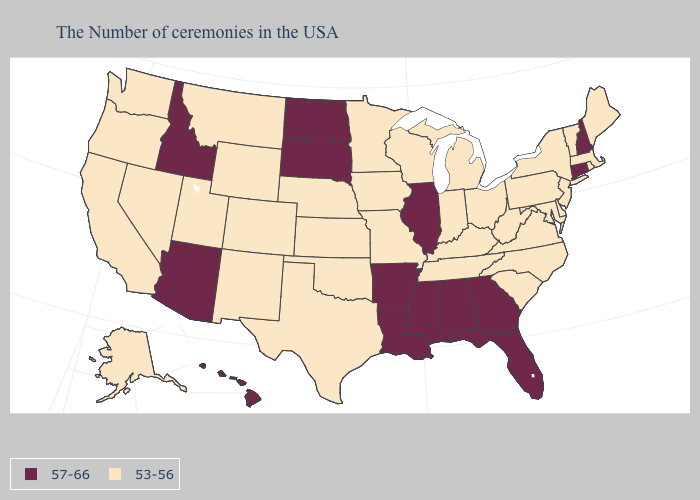Which states have the highest value in the USA?
Keep it brief. New Hampshire, Connecticut, Florida, Georgia, Alabama, Illinois, Mississippi, Louisiana, Arkansas, South Dakota, North Dakota, Arizona, Idaho, Hawaii. Among the states that border New York , which have the highest value?
Keep it brief. Connecticut. What is the value of South Carolina?
Concise answer only. 53-56. What is the lowest value in the Northeast?
Answer briefly. 53-56. Which states have the lowest value in the USA?
Answer briefly. Maine, Massachusetts, Rhode Island, Vermont, New York, New Jersey, Delaware, Maryland, Pennsylvania, Virginia, North Carolina, South Carolina, West Virginia, Ohio, Michigan, Kentucky, Indiana, Tennessee, Wisconsin, Missouri, Minnesota, Iowa, Kansas, Nebraska, Oklahoma, Texas, Wyoming, Colorado, New Mexico, Utah, Montana, Nevada, California, Washington, Oregon, Alaska. What is the value of California?
Be succinct. 53-56. Which states have the highest value in the USA?
Concise answer only. New Hampshire, Connecticut, Florida, Georgia, Alabama, Illinois, Mississippi, Louisiana, Arkansas, South Dakota, North Dakota, Arizona, Idaho, Hawaii. What is the value of Oklahoma?
Answer briefly. 53-56. Among the states that border California , does Arizona have the highest value?
Short answer required. Yes. Name the states that have a value in the range 57-66?
Short answer required. New Hampshire, Connecticut, Florida, Georgia, Alabama, Illinois, Mississippi, Louisiana, Arkansas, South Dakota, North Dakota, Arizona, Idaho, Hawaii. Name the states that have a value in the range 57-66?
Keep it brief. New Hampshire, Connecticut, Florida, Georgia, Alabama, Illinois, Mississippi, Louisiana, Arkansas, South Dakota, North Dakota, Arizona, Idaho, Hawaii. Does the map have missing data?
Give a very brief answer. No. Does the map have missing data?
Concise answer only. No. What is the value of Florida?
Short answer required. 57-66. 